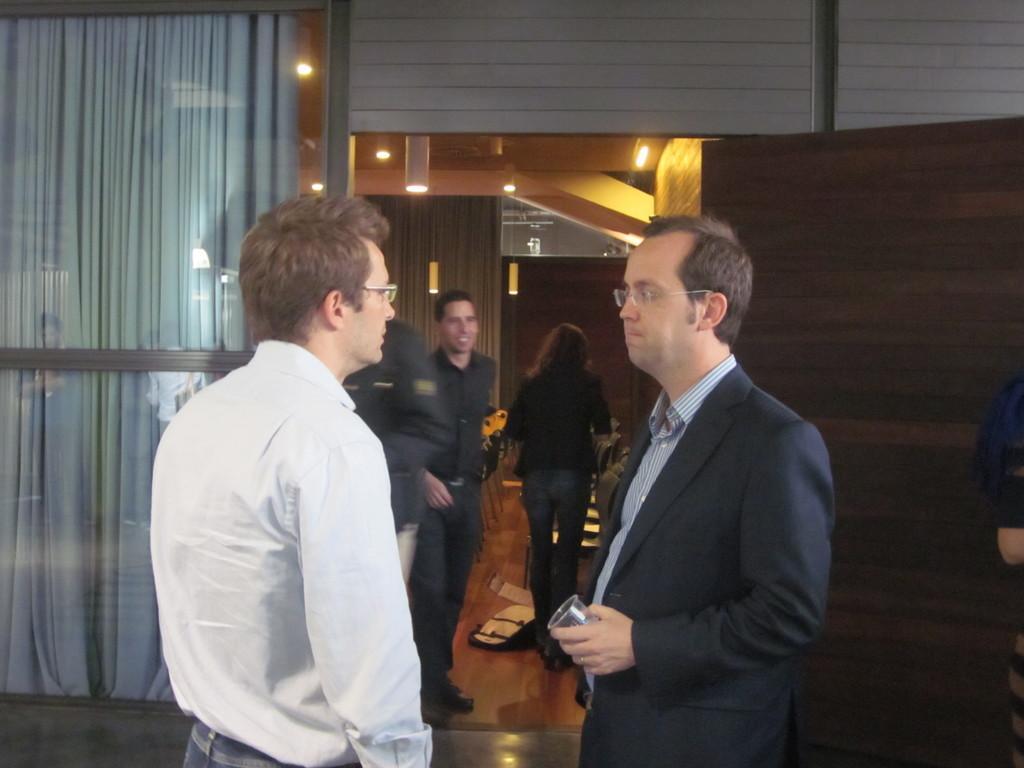In one or two sentences, can you explain what this image depicts? There are few persons on the floor. Here we can see a glass, curtains, lights, door, and wall. 